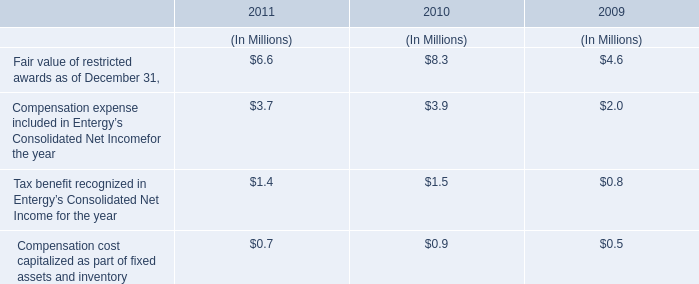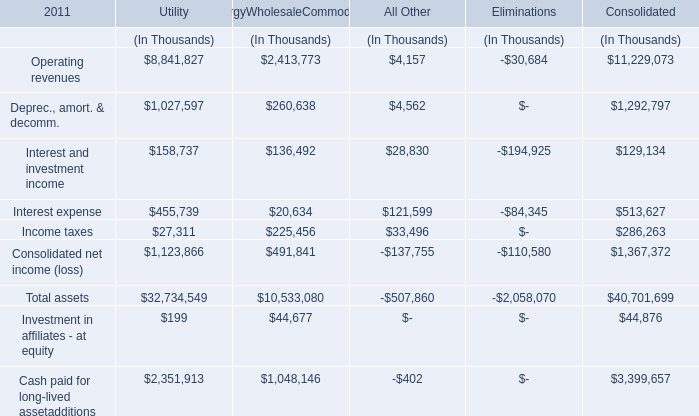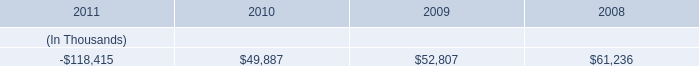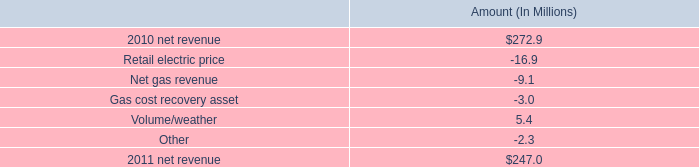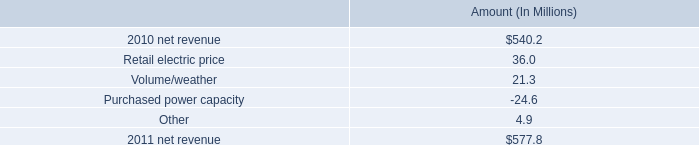what is the average price per gwh for the variance in volume? 
Computations: ((21.3 - 1000000) / 721)
Answer: -1386.93301. 